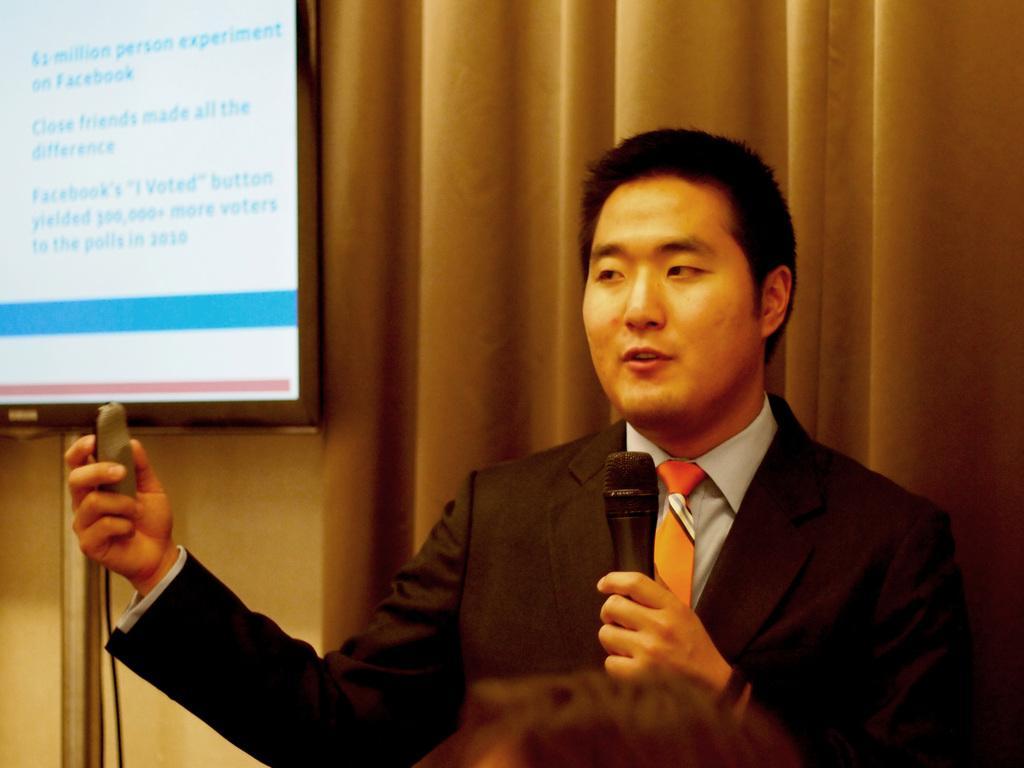Could you give a brief overview of what you see in this image? In the foreground of this image, there is a man holding a mic and an object in his hands. At the bottom, there is a head of a person. In the background, there is a screen and the curtain. 